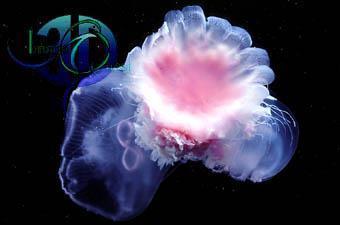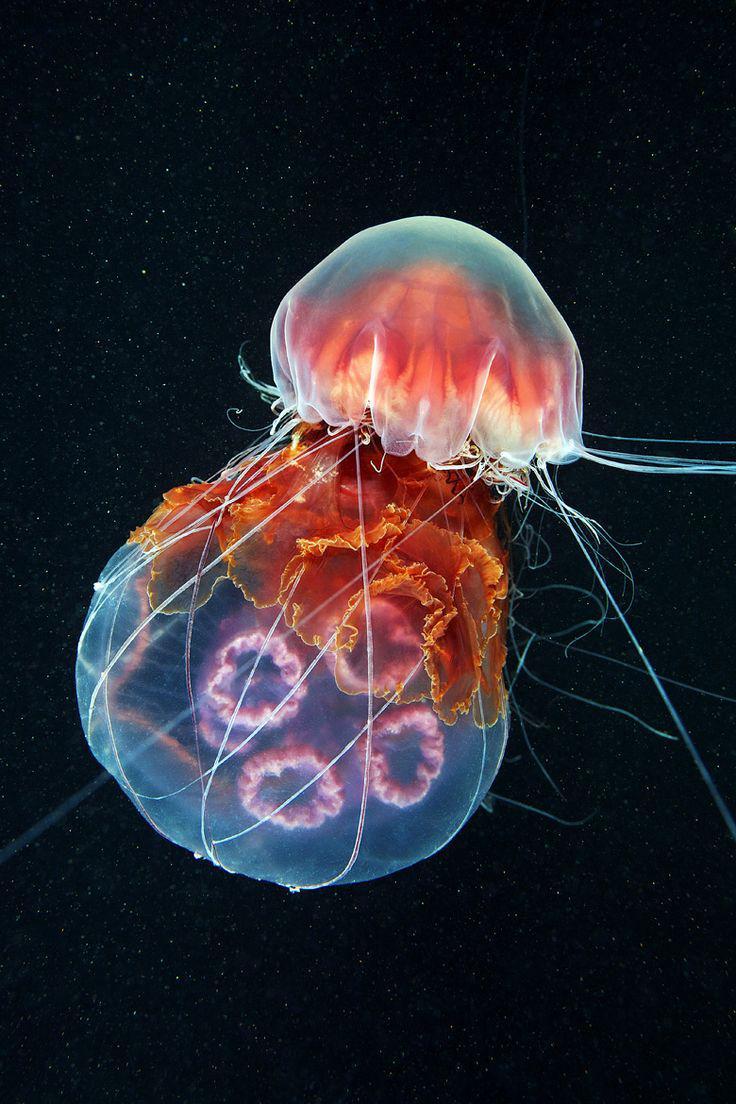The first image is the image on the left, the second image is the image on the right. Considering the images on both sides, is "Each image includes a jellyfish with multiple threadlike tentacles, and each jellyfish image has a blue-green multi-tone background." valid? Answer yes or no. No. The first image is the image on the left, the second image is the image on the right. For the images shown, is this caption "In at least one of the images, there is greenish light coming through the water above the jellyfish." true? Answer yes or no. No. 